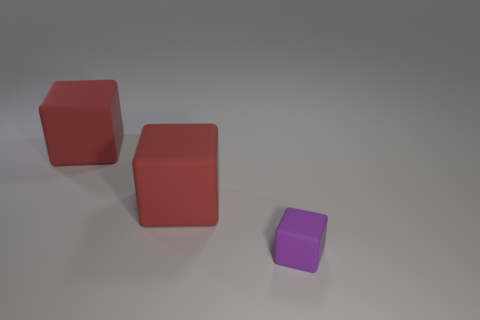How many objects are matte blocks behind the small rubber thing or blocks left of the purple rubber thing? There are two matte blocks situated behind the small rubber object. Additionally, all of the blocks, including the two large ones and one smaller one, are positioned to the left of the purple rubber object. 